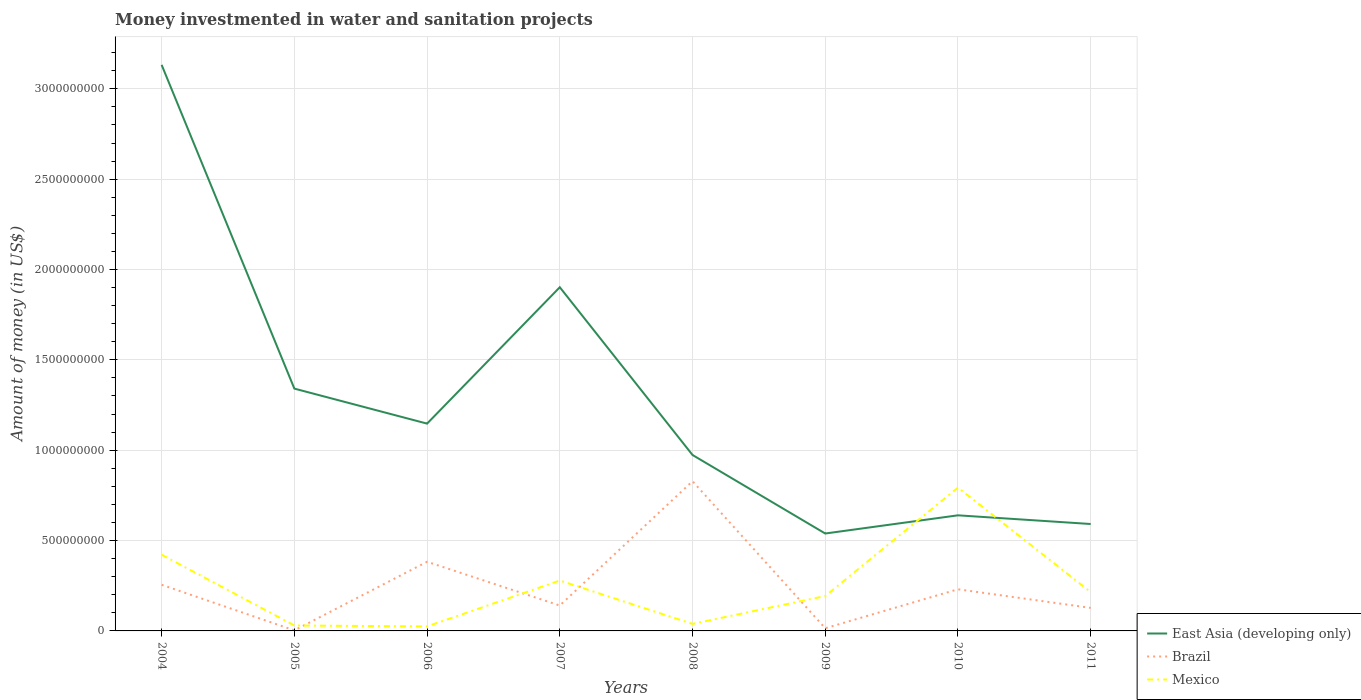How many different coloured lines are there?
Your answer should be compact. 3. Across all years, what is the maximum money investmented in water and sanitation projects in Mexico?
Your answer should be very brief. 2.50e+07. In which year was the money investmented in water and sanitation projects in East Asia (developing only) maximum?
Offer a very short reply. 2009. What is the total money investmented in water and sanitation projects in Mexico in the graph?
Keep it short and to the point. 2.29e+08. What is the difference between the highest and the second highest money investmented in water and sanitation projects in East Asia (developing only)?
Offer a very short reply. 2.59e+09. What is the difference between two consecutive major ticks on the Y-axis?
Give a very brief answer. 5.00e+08. Are the values on the major ticks of Y-axis written in scientific E-notation?
Make the answer very short. No. Does the graph contain any zero values?
Your response must be concise. No. Does the graph contain grids?
Ensure brevity in your answer.  Yes. Where does the legend appear in the graph?
Your answer should be very brief. Bottom right. How many legend labels are there?
Offer a terse response. 3. What is the title of the graph?
Offer a very short reply. Money investmented in water and sanitation projects. Does "Belgium" appear as one of the legend labels in the graph?
Provide a short and direct response. No. What is the label or title of the Y-axis?
Give a very brief answer. Amount of money (in US$). What is the Amount of money (in US$) of East Asia (developing only) in 2004?
Your answer should be very brief. 3.13e+09. What is the Amount of money (in US$) in Brazil in 2004?
Offer a very short reply. 2.55e+08. What is the Amount of money (in US$) in Mexico in 2004?
Offer a very short reply. 4.22e+08. What is the Amount of money (in US$) of East Asia (developing only) in 2005?
Provide a succinct answer. 1.34e+09. What is the Amount of money (in US$) in Brazil in 2005?
Your answer should be very brief. 3.16e+06. What is the Amount of money (in US$) in Mexico in 2005?
Your answer should be very brief. 3.00e+07. What is the Amount of money (in US$) of East Asia (developing only) in 2006?
Offer a terse response. 1.15e+09. What is the Amount of money (in US$) in Brazil in 2006?
Give a very brief answer. 3.83e+08. What is the Amount of money (in US$) in Mexico in 2006?
Make the answer very short. 2.50e+07. What is the Amount of money (in US$) in East Asia (developing only) in 2007?
Make the answer very short. 1.90e+09. What is the Amount of money (in US$) in Brazil in 2007?
Give a very brief answer. 1.41e+08. What is the Amount of money (in US$) of Mexico in 2007?
Keep it short and to the point. 2.79e+08. What is the Amount of money (in US$) in East Asia (developing only) in 2008?
Give a very brief answer. 9.74e+08. What is the Amount of money (in US$) in Brazil in 2008?
Keep it short and to the point. 8.28e+08. What is the Amount of money (in US$) of Mexico in 2008?
Your answer should be compact. 3.89e+07. What is the Amount of money (in US$) of East Asia (developing only) in 2009?
Your response must be concise. 5.39e+08. What is the Amount of money (in US$) in Brazil in 2009?
Keep it short and to the point. 1.48e+07. What is the Amount of money (in US$) of Mexico in 2009?
Ensure brevity in your answer.  1.93e+08. What is the Amount of money (in US$) of East Asia (developing only) in 2010?
Offer a terse response. 6.40e+08. What is the Amount of money (in US$) of Brazil in 2010?
Your response must be concise. 2.30e+08. What is the Amount of money (in US$) in Mexico in 2010?
Ensure brevity in your answer.  7.93e+08. What is the Amount of money (in US$) in East Asia (developing only) in 2011?
Your response must be concise. 5.92e+08. What is the Amount of money (in US$) of Brazil in 2011?
Ensure brevity in your answer.  1.28e+08. What is the Amount of money (in US$) of Mexico in 2011?
Offer a very short reply. 2.15e+08. Across all years, what is the maximum Amount of money (in US$) of East Asia (developing only)?
Give a very brief answer. 3.13e+09. Across all years, what is the maximum Amount of money (in US$) in Brazil?
Your response must be concise. 8.28e+08. Across all years, what is the maximum Amount of money (in US$) of Mexico?
Your answer should be very brief. 7.93e+08. Across all years, what is the minimum Amount of money (in US$) in East Asia (developing only)?
Your answer should be very brief. 5.39e+08. Across all years, what is the minimum Amount of money (in US$) in Brazil?
Make the answer very short. 3.16e+06. Across all years, what is the minimum Amount of money (in US$) in Mexico?
Keep it short and to the point. 2.50e+07. What is the total Amount of money (in US$) in East Asia (developing only) in the graph?
Provide a short and direct response. 1.03e+1. What is the total Amount of money (in US$) in Brazil in the graph?
Make the answer very short. 1.98e+09. What is the total Amount of money (in US$) in Mexico in the graph?
Provide a succinct answer. 2.00e+09. What is the difference between the Amount of money (in US$) in East Asia (developing only) in 2004 and that in 2005?
Offer a terse response. 1.79e+09. What is the difference between the Amount of money (in US$) in Brazil in 2004 and that in 2005?
Your response must be concise. 2.52e+08. What is the difference between the Amount of money (in US$) of Mexico in 2004 and that in 2005?
Make the answer very short. 3.92e+08. What is the difference between the Amount of money (in US$) in East Asia (developing only) in 2004 and that in 2006?
Ensure brevity in your answer.  1.99e+09. What is the difference between the Amount of money (in US$) in Brazil in 2004 and that in 2006?
Provide a short and direct response. -1.27e+08. What is the difference between the Amount of money (in US$) of Mexico in 2004 and that in 2006?
Provide a succinct answer. 3.97e+08. What is the difference between the Amount of money (in US$) in East Asia (developing only) in 2004 and that in 2007?
Give a very brief answer. 1.23e+09. What is the difference between the Amount of money (in US$) in Brazil in 2004 and that in 2007?
Your answer should be very brief. 1.15e+08. What is the difference between the Amount of money (in US$) of Mexico in 2004 and that in 2007?
Provide a short and direct response. 1.43e+08. What is the difference between the Amount of money (in US$) in East Asia (developing only) in 2004 and that in 2008?
Your answer should be very brief. 2.16e+09. What is the difference between the Amount of money (in US$) in Brazil in 2004 and that in 2008?
Give a very brief answer. -5.73e+08. What is the difference between the Amount of money (in US$) of Mexico in 2004 and that in 2008?
Provide a short and direct response. 3.83e+08. What is the difference between the Amount of money (in US$) in East Asia (developing only) in 2004 and that in 2009?
Your answer should be compact. 2.59e+09. What is the difference between the Amount of money (in US$) in Brazil in 2004 and that in 2009?
Give a very brief answer. 2.41e+08. What is the difference between the Amount of money (in US$) in Mexico in 2004 and that in 2009?
Your response must be concise. 2.29e+08. What is the difference between the Amount of money (in US$) of East Asia (developing only) in 2004 and that in 2010?
Provide a succinct answer. 2.49e+09. What is the difference between the Amount of money (in US$) in Brazil in 2004 and that in 2010?
Make the answer very short. 2.49e+07. What is the difference between the Amount of money (in US$) of Mexico in 2004 and that in 2010?
Give a very brief answer. -3.71e+08. What is the difference between the Amount of money (in US$) of East Asia (developing only) in 2004 and that in 2011?
Your answer should be very brief. 2.54e+09. What is the difference between the Amount of money (in US$) of Brazil in 2004 and that in 2011?
Your answer should be compact. 1.28e+08. What is the difference between the Amount of money (in US$) in Mexico in 2004 and that in 2011?
Your answer should be compact. 2.07e+08. What is the difference between the Amount of money (in US$) of East Asia (developing only) in 2005 and that in 2006?
Provide a short and direct response. 1.94e+08. What is the difference between the Amount of money (in US$) in Brazil in 2005 and that in 2006?
Offer a terse response. -3.79e+08. What is the difference between the Amount of money (in US$) in East Asia (developing only) in 2005 and that in 2007?
Give a very brief answer. -5.61e+08. What is the difference between the Amount of money (in US$) of Brazil in 2005 and that in 2007?
Keep it short and to the point. -1.37e+08. What is the difference between the Amount of money (in US$) in Mexico in 2005 and that in 2007?
Make the answer very short. -2.49e+08. What is the difference between the Amount of money (in US$) of East Asia (developing only) in 2005 and that in 2008?
Give a very brief answer. 3.67e+08. What is the difference between the Amount of money (in US$) in Brazil in 2005 and that in 2008?
Make the answer very short. -8.25e+08. What is the difference between the Amount of money (in US$) in Mexico in 2005 and that in 2008?
Provide a succinct answer. -8.90e+06. What is the difference between the Amount of money (in US$) of East Asia (developing only) in 2005 and that in 2009?
Ensure brevity in your answer.  8.02e+08. What is the difference between the Amount of money (in US$) of Brazil in 2005 and that in 2009?
Keep it short and to the point. -1.16e+07. What is the difference between the Amount of money (in US$) in Mexico in 2005 and that in 2009?
Keep it short and to the point. -1.63e+08. What is the difference between the Amount of money (in US$) in East Asia (developing only) in 2005 and that in 2010?
Offer a very short reply. 7.01e+08. What is the difference between the Amount of money (in US$) of Brazil in 2005 and that in 2010?
Your response must be concise. -2.27e+08. What is the difference between the Amount of money (in US$) of Mexico in 2005 and that in 2010?
Your answer should be very brief. -7.63e+08. What is the difference between the Amount of money (in US$) of East Asia (developing only) in 2005 and that in 2011?
Provide a short and direct response. 7.49e+08. What is the difference between the Amount of money (in US$) in Brazil in 2005 and that in 2011?
Ensure brevity in your answer.  -1.24e+08. What is the difference between the Amount of money (in US$) of Mexico in 2005 and that in 2011?
Offer a terse response. -1.85e+08. What is the difference between the Amount of money (in US$) in East Asia (developing only) in 2006 and that in 2007?
Give a very brief answer. -7.55e+08. What is the difference between the Amount of money (in US$) in Brazil in 2006 and that in 2007?
Your answer should be compact. 2.42e+08. What is the difference between the Amount of money (in US$) of Mexico in 2006 and that in 2007?
Your answer should be compact. -2.54e+08. What is the difference between the Amount of money (in US$) in East Asia (developing only) in 2006 and that in 2008?
Give a very brief answer. 1.74e+08. What is the difference between the Amount of money (in US$) of Brazil in 2006 and that in 2008?
Give a very brief answer. -4.46e+08. What is the difference between the Amount of money (in US$) of Mexico in 2006 and that in 2008?
Offer a terse response. -1.39e+07. What is the difference between the Amount of money (in US$) in East Asia (developing only) in 2006 and that in 2009?
Keep it short and to the point. 6.08e+08. What is the difference between the Amount of money (in US$) in Brazil in 2006 and that in 2009?
Offer a terse response. 3.68e+08. What is the difference between the Amount of money (in US$) in Mexico in 2006 and that in 2009?
Your answer should be very brief. -1.68e+08. What is the difference between the Amount of money (in US$) in East Asia (developing only) in 2006 and that in 2010?
Give a very brief answer. 5.07e+08. What is the difference between the Amount of money (in US$) of Brazil in 2006 and that in 2010?
Make the answer very short. 1.52e+08. What is the difference between the Amount of money (in US$) of Mexico in 2006 and that in 2010?
Your answer should be compact. -7.68e+08. What is the difference between the Amount of money (in US$) of East Asia (developing only) in 2006 and that in 2011?
Make the answer very short. 5.56e+08. What is the difference between the Amount of money (in US$) of Brazil in 2006 and that in 2011?
Ensure brevity in your answer.  2.55e+08. What is the difference between the Amount of money (in US$) of Mexico in 2006 and that in 2011?
Give a very brief answer. -1.90e+08. What is the difference between the Amount of money (in US$) of East Asia (developing only) in 2007 and that in 2008?
Your response must be concise. 9.28e+08. What is the difference between the Amount of money (in US$) of Brazil in 2007 and that in 2008?
Your answer should be very brief. -6.88e+08. What is the difference between the Amount of money (in US$) of Mexico in 2007 and that in 2008?
Your answer should be very brief. 2.40e+08. What is the difference between the Amount of money (in US$) of East Asia (developing only) in 2007 and that in 2009?
Your response must be concise. 1.36e+09. What is the difference between the Amount of money (in US$) of Brazil in 2007 and that in 2009?
Make the answer very short. 1.26e+08. What is the difference between the Amount of money (in US$) in Mexico in 2007 and that in 2009?
Ensure brevity in your answer.  8.58e+07. What is the difference between the Amount of money (in US$) in East Asia (developing only) in 2007 and that in 2010?
Provide a short and direct response. 1.26e+09. What is the difference between the Amount of money (in US$) of Brazil in 2007 and that in 2010?
Give a very brief answer. -8.98e+07. What is the difference between the Amount of money (in US$) in Mexico in 2007 and that in 2010?
Make the answer very short. -5.14e+08. What is the difference between the Amount of money (in US$) of East Asia (developing only) in 2007 and that in 2011?
Provide a succinct answer. 1.31e+09. What is the difference between the Amount of money (in US$) in Brazil in 2007 and that in 2011?
Offer a very short reply. 1.31e+07. What is the difference between the Amount of money (in US$) of Mexico in 2007 and that in 2011?
Keep it short and to the point. 6.40e+07. What is the difference between the Amount of money (in US$) in East Asia (developing only) in 2008 and that in 2009?
Ensure brevity in your answer.  4.35e+08. What is the difference between the Amount of money (in US$) in Brazil in 2008 and that in 2009?
Keep it short and to the point. 8.14e+08. What is the difference between the Amount of money (in US$) of Mexico in 2008 and that in 2009?
Provide a short and direct response. -1.54e+08. What is the difference between the Amount of money (in US$) in East Asia (developing only) in 2008 and that in 2010?
Ensure brevity in your answer.  3.34e+08. What is the difference between the Amount of money (in US$) of Brazil in 2008 and that in 2010?
Give a very brief answer. 5.98e+08. What is the difference between the Amount of money (in US$) of Mexico in 2008 and that in 2010?
Offer a very short reply. -7.54e+08. What is the difference between the Amount of money (in US$) in East Asia (developing only) in 2008 and that in 2011?
Your response must be concise. 3.82e+08. What is the difference between the Amount of money (in US$) in Brazil in 2008 and that in 2011?
Keep it short and to the point. 7.01e+08. What is the difference between the Amount of money (in US$) in Mexico in 2008 and that in 2011?
Offer a very short reply. -1.76e+08. What is the difference between the Amount of money (in US$) of East Asia (developing only) in 2009 and that in 2010?
Offer a terse response. -1.01e+08. What is the difference between the Amount of money (in US$) in Brazil in 2009 and that in 2010?
Ensure brevity in your answer.  -2.16e+08. What is the difference between the Amount of money (in US$) in Mexico in 2009 and that in 2010?
Give a very brief answer. -6.00e+08. What is the difference between the Amount of money (in US$) of East Asia (developing only) in 2009 and that in 2011?
Provide a succinct answer. -5.26e+07. What is the difference between the Amount of money (in US$) in Brazil in 2009 and that in 2011?
Offer a very short reply. -1.13e+08. What is the difference between the Amount of money (in US$) in Mexico in 2009 and that in 2011?
Your response must be concise. -2.18e+07. What is the difference between the Amount of money (in US$) of East Asia (developing only) in 2010 and that in 2011?
Your answer should be compact. 4.81e+07. What is the difference between the Amount of money (in US$) in Brazil in 2010 and that in 2011?
Keep it short and to the point. 1.03e+08. What is the difference between the Amount of money (in US$) in Mexico in 2010 and that in 2011?
Offer a very short reply. 5.78e+08. What is the difference between the Amount of money (in US$) in East Asia (developing only) in 2004 and the Amount of money (in US$) in Brazil in 2005?
Provide a succinct answer. 3.13e+09. What is the difference between the Amount of money (in US$) of East Asia (developing only) in 2004 and the Amount of money (in US$) of Mexico in 2005?
Ensure brevity in your answer.  3.10e+09. What is the difference between the Amount of money (in US$) of Brazil in 2004 and the Amount of money (in US$) of Mexico in 2005?
Provide a short and direct response. 2.25e+08. What is the difference between the Amount of money (in US$) of East Asia (developing only) in 2004 and the Amount of money (in US$) of Brazil in 2006?
Your answer should be very brief. 2.75e+09. What is the difference between the Amount of money (in US$) in East Asia (developing only) in 2004 and the Amount of money (in US$) in Mexico in 2006?
Keep it short and to the point. 3.11e+09. What is the difference between the Amount of money (in US$) in Brazil in 2004 and the Amount of money (in US$) in Mexico in 2006?
Your response must be concise. 2.30e+08. What is the difference between the Amount of money (in US$) of East Asia (developing only) in 2004 and the Amount of money (in US$) of Brazil in 2007?
Ensure brevity in your answer.  2.99e+09. What is the difference between the Amount of money (in US$) in East Asia (developing only) in 2004 and the Amount of money (in US$) in Mexico in 2007?
Provide a succinct answer. 2.85e+09. What is the difference between the Amount of money (in US$) of Brazil in 2004 and the Amount of money (in US$) of Mexico in 2007?
Ensure brevity in your answer.  -2.35e+07. What is the difference between the Amount of money (in US$) of East Asia (developing only) in 2004 and the Amount of money (in US$) of Brazil in 2008?
Provide a succinct answer. 2.30e+09. What is the difference between the Amount of money (in US$) of East Asia (developing only) in 2004 and the Amount of money (in US$) of Mexico in 2008?
Ensure brevity in your answer.  3.09e+09. What is the difference between the Amount of money (in US$) in Brazil in 2004 and the Amount of money (in US$) in Mexico in 2008?
Keep it short and to the point. 2.16e+08. What is the difference between the Amount of money (in US$) of East Asia (developing only) in 2004 and the Amount of money (in US$) of Brazil in 2009?
Give a very brief answer. 3.12e+09. What is the difference between the Amount of money (in US$) in East Asia (developing only) in 2004 and the Amount of money (in US$) in Mexico in 2009?
Your answer should be compact. 2.94e+09. What is the difference between the Amount of money (in US$) of Brazil in 2004 and the Amount of money (in US$) of Mexico in 2009?
Your answer should be very brief. 6.23e+07. What is the difference between the Amount of money (in US$) in East Asia (developing only) in 2004 and the Amount of money (in US$) in Brazil in 2010?
Make the answer very short. 2.90e+09. What is the difference between the Amount of money (in US$) in East Asia (developing only) in 2004 and the Amount of money (in US$) in Mexico in 2010?
Provide a succinct answer. 2.34e+09. What is the difference between the Amount of money (in US$) of Brazil in 2004 and the Amount of money (in US$) of Mexico in 2010?
Give a very brief answer. -5.38e+08. What is the difference between the Amount of money (in US$) in East Asia (developing only) in 2004 and the Amount of money (in US$) in Brazil in 2011?
Provide a short and direct response. 3.00e+09. What is the difference between the Amount of money (in US$) in East Asia (developing only) in 2004 and the Amount of money (in US$) in Mexico in 2011?
Make the answer very short. 2.92e+09. What is the difference between the Amount of money (in US$) in Brazil in 2004 and the Amount of money (in US$) in Mexico in 2011?
Provide a short and direct response. 4.05e+07. What is the difference between the Amount of money (in US$) in East Asia (developing only) in 2005 and the Amount of money (in US$) in Brazil in 2006?
Provide a short and direct response. 9.58e+08. What is the difference between the Amount of money (in US$) of East Asia (developing only) in 2005 and the Amount of money (in US$) of Mexico in 2006?
Provide a short and direct response. 1.32e+09. What is the difference between the Amount of money (in US$) of Brazil in 2005 and the Amount of money (in US$) of Mexico in 2006?
Give a very brief answer. -2.18e+07. What is the difference between the Amount of money (in US$) of East Asia (developing only) in 2005 and the Amount of money (in US$) of Brazil in 2007?
Keep it short and to the point. 1.20e+09. What is the difference between the Amount of money (in US$) in East Asia (developing only) in 2005 and the Amount of money (in US$) in Mexico in 2007?
Offer a very short reply. 1.06e+09. What is the difference between the Amount of money (in US$) of Brazil in 2005 and the Amount of money (in US$) of Mexico in 2007?
Make the answer very short. -2.76e+08. What is the difference between the Amount of money (in US$) in East Asia (developing only) in 2005 and the Amount of money (in US$) in Brazil in 2008?
Provide a succinct answer. 5.13e+08. What is the difference between the Amount of money (in US$) of East Asia (developing only) in 2005 and the Amount of money (in US$) of Mexico in 2008?
Your answer should be very brief. 1.30e+09. What is the difference between the Amount of money (in US$) in Brazil in 2005 and the Amount of money (in US$) in Mexico in 2008?
Keep it short and to the point. -3.57e+07. What is the difference between the Amount of money (in US$) in East Asia (developing only) in 2005 and the Amount of money (in US$) in Brazil in 2009?
Make the answer very short. 1.33e+09. What is the difference between the Amount of money (in US$) in East Asia (developing only) in 2005 and the Amount of money (in US$) in Mexico in 2009?
Keep it short and to the point. 1.15e+09. What is the difference between the Amount of money (in US$) of Brazil in 2005 and the Amount of money (in US$) of Mexico in 2009?
Your answer should be very brief. -1.90e+08. What is the difference between the Amount of money (in US$) in East Asia (developing only) in 2005 and the Amount of money (in US$) in Brazil in 2010?
Give a very brief answer. 1.11e+09. What is the difference between the Amount of money (in US$) in East Asia (developing only) in 2005 and the Amount of money (in US$) in Mexico in 2010?
Your answer should be compact. 5.48e+08. What is the difference between the Amount of money (in US$) of Brazil in 2005 and the Amount of money (in US$) of Mexico in 2010?
Offer a terse response. -7.90e+08. What is the difference between the Amount of money (in US$) in East Asia (developing only) in 2005 and the Amount of money (in US$) in Brazil in 2011?
Provide a succinct answer. 1.21e+09. What is the difference between the Amount of money (in US$) in East Asia (developing only) in 2005 and the Amount of money (in US$) in Mexico in 2011?
Offer a terse response. 1.13e+09. What is the difference between the Amount of money (in US$) of Brazil in 2005 and the Amount of money (in US$) of Mexico in 2011?
Your response must be concise. -2.12e+08. What is the difference between the Amount of money (in US$) in East Asia (developing only) in 2006 and the Amount of money (in US$) in Brazil in 2007?
Your response must be concise. 1.01e+09. What is the difference between the Amount of money (in US$) of East Asia (developing only) in 2006 and the Amount of money (in US$) of Mexico in 2007?
Give a very brief answer. 8.68e+08. What is the difference between the Amount of money (in US$) in Brazil in 2006 and the Amount of money (in US$) in Mexico in 2007?
Keep it short and to the point. 1.04e+08. What is the difference between the Amount of money (in US$) in East Asia (developing only) in 2006 and the Amount of money (in US$) in Brazil in 2008?
Provide a short and direct response. 3.19e+08. What is the difference between the Amount of money (in US$) of East Asia (developing only) in 2006 and the Amount of money (in US$) of Mexico in 2008?
Offer a terse response. 1.11e+09. What is the difference between the Amount of money (in US$) in Brazil in 2006 and the Amount of money (in US$) in Mexico in 2008?
Offer a terse response. 3.44e+08. What is the difference between the Amount of money (in US$) of East Asia (developing only) in 2006 and the Amount of money (in US$) of Brazil in 2009?
Your response must be concise. 1.13e+09. What is the difference between the Amount of money (in US$) in East Asia (developing only) in 2006 and the Amount of money (in US$) in Mexico in 2009?
Provide a short and direct response. 9.54e+08. What is the difference between the Amount of money (in US$) in Brazil in 2006 and the Amount of money (in US$) in Mexico in 2009?
Make the answer very short. 1.90e+08. What is the difference between the Amount of money (in US$) of East Asia (developing only) in 2006 and the Amount of money (in US$) of Brazil in 2010?
Provide a short and direct response. 9.17e+08. What is the difference between the Amount of money (in US$) in East Asia (developing only) in 2006 and the Amount of money (in US$) in Mexico in 2010?
Your answer should be very brief. 3.54e+08. What is the difference between the Amount of money (in US$) in Brazil in 2006 and the Amount of money (in US$) in Mexico in 2010?
Provide a succinct answer. -4.10e+08. What is the difference between the Amount of money (in US$) of East Asia (developing only) in 2006 and the Amount of money (in US$) of Brazil in 2011?
Your response must be concise. 1.02e+09. What is the difference between the Amount of money (in US$) in East Asia (developing only) in 2006 and the Amount of money (in US$) in Mexico in 2011?
Your answer should be compact. 9.32e+08. What is the difference between the Amount of money (in US$) of Brazil in 2006 and the Amount of money (in US$) of Mexico in 2011?
Ensure brevity in your answer.  1.68e+08. What is the difference between the Amount of money (in US$) of East Asia (developing only) in 2007 and the Amount of money (in US$) of Brazil in 2008?
Ensure brevity in your answer.  1.07e+09. What is the difference between the Amount of money (in US$) of East Asia (developing only) in 2007 and the Amount of money (in US$) of Mexico in 2008?
Offer a very short reply. 1.86e+09. What is the difference between the Amount of money (in US$) in Brazil in 2007 and the Amount of money (in US$) in Mexico in 2008?
Keep it short and to the point. 1.02e+08. What is the difference between the Amount of money (in US$) in East Asia (developing only) in 2007 and the Amount of money (in US$) in Brazil in 2009?
Offer a terse response. 1.89e+09. What is the difference between the Amount of money (in US$) in East Asia (developing only) in 2007 and the Amount of money (in US$) in Mexico in 2009?
Provide a short and direct response. 1.71e+09. What is the difference between the Amount of money (in US$) in Brazil in 2007 and the Amount of money (in US$) in Mexico in 2009?
Your answer should be very brief. -5.24e+07. What is the difference between the Amount of money (in US$) of East Asia (developing only) in 2007 and the Amount of money (in US$) of Brazil in 2010?
Offer a terse response. 1.67e+09. What is the difference between the Amount of money (in US$) of East Asia (developing only) in 2007 and the Amount of money (in US$) of Mexico in 2010?
Your answer should be compact. 1.11e+09. What is the difference between the Amount of money (in US$) of Brazil in 2007 and the Amount of money (in US$) of Mexico in 2010?
Keep it short and to the point. -6.52e+08. What is the difference between the Amount of money (in US$) in East Asia (developing only) in 2007 and the Amount of money (in US$) in Brazil in 2011?
Offer a terse response. 1.77e+09. What is the difference between the Amount of money (in US$) in East Asia (developing only) in 2007 and the Amount of money (in US$) in Mexico in 2011?
Ensure brevity in your answer.  1.69e+09. What is the difference between the Amount of money (in US$) in Brazil in 2007 and the Amount of money (in US$) in Mexico in 2011?
Provide a short and direct response. -7.42e+07. What is the difference between the Amount of money (in US$) of East Asia (developing only) in 2008 and the Amount of money (in US$) of Brazil in 2009?
Your response must be concise. 9.59e+08. What is the difference between the Amount of money (in US$) of East Asia (developing only) in 2008 and the Amount of money (in US$) of Mexico in 2009?
Make the answer very short. 7.81e+08. What is the difference between the Amount of money (in US$) of Brazil in 2008 and the Amount of money (in US$) of Mexico in 2009?
Your answer should be compact. 6.35e+08. What is the difference between the Amount of money (in US$) of East Asia (developing only) in 2008 and the Amount of money (in US$) of Brazil in 2010?
Provide a short and direct response. 7.43e+08. What is the difference between the Amount of money (in US$) of East Asia (developing only) in 2008 and the Amount of money (in US$) of Mexico in 2010?
Offer a very short reply. 1.81e+08. What is the difference between the Amount of money (in US$) of Brazil in 2008 and the Amount of money (in US$) of Mexico in 2010?
Your answer should be very brief. 3.54e+07. What is the difference between the Amount of money (in US$) in East Asia (developing only) in 2008 and the Amount of money (in US$) in Brazil in 2011?
Make the answer very short. 8.46e+08. What is the difference between the Amount of money (in US$) of East Asia (developing only) in 2008 and the Amount of money (in US$) of Mexico in 2011?
Offer a terse response. 7.59e+08. What is the difference between the Amount of money (in US$) in Brazil in 2008 and the Amount of money (in US$) in Mexico in 2011?
Keep it short and to the point. 6.14e+08. What is the difference between the Amount of money (in US$) in East Asia (developing only) in 2009 and the Amount of money (in US$) in Brazil in 2010?
Ensure brevity in your answer.  3.09e+08. What is the difference between the Amount of money (in US$) of East Asia (developing only) in 2009 and the Amount of money (in US$) of Mexico in 2010?
Your response must be concise. -2.54e+08. What is the difference between the Amount of money (in US$) of Brazil in 2009 and the Amount of money (in US$) of Mexico in 2010?
Your answer should be very brief. -7.78e+08. What is the difference between the Amount of money (in US$) in East Asia (developing only) in 2009 and the Amount of money (in US$) in Brazil in 2011?
Make the answer very short. 4.12e+08. What is the difference between the Amount of money (in US$) of East Asia (developing only) in 2009 and the Amount of money (in US$) of Mexico in 2011?
Make the answer very short. 3.24e+08. What is the difference between the Amount of money (in US$) in Brazil in 2009 and the Amount of money (in US$) in Mexico in 2011?
Ensure brevity in your answer.  -2.00e+08. What is the difference between the Amount of money (in US$) of East Asia (developing only) in 2010 and the Amount of money (in US$) of Brazil in 2011?
Provide a succinct answer. 5.12e+08. What is the difference between the Amount of money (in US$) of East Asia (developing only) in 2010 and the Amount of money (in US$) of Mexico in 2011?
Ensure brevity in your answer.  4.25e+08. What is the difference between the Amount of money (in US$) of Brazil in 2010 and the Amount of money (in US$) of Mexico in 2011?
Your answer should be compact. 1.56e+07. What is the average Amount of money (in US$) in East Asia (developing only) per year?
Ensure brevity in your answer.  1.28e+09. What is the average Amount of money (in US$) of Brazil per year?
Make the answer very short. 2.48e+08. What is the average Amount of money (in US$) in Mexico per year?
Offer a very short reply. 2.49e+08. In the year 2004, what is the difference between the Amount of money (in US$) of East Asia (developing only) and Amount of money (in US$) of Brazil?
Keep it short and to the point. 2.88e+09. In the year 2004, what is the difference between the Amount of money (in US$) of East Asia (developing only) and Amount of money (in US$) of Mexico?
Your response must be concise. 2.71e+09. In the year 2004, what is the difference between the Amount of money (in US$) in Brazil and Amount of money (in US$) in Mexico?
Provide a succinct answer. -1.66e+08. In the year 2005, what is the difference between the Amount of money (in US$) of East Asia (developing only) and Amount of money (in US$) of Brazil?
Offer a very short reply. 1.34e+09. In the year 2005, what is the difference between the Amount of money (in US$) of East Asia (developing only) and Amount of money (in US$) of Mexico?
Provide a short and direct response. 1.31e+09. In the year 2005, what is the difference between the Amount of money (in US$) of Brazil and Amount of money (in US$) of Mexico?
Offer a very short reply. -2.68e+07. In the year 2006, what is the difference between the Amount of money (in US$) of East Asia (developing only) and Amount of money (in US$) of Brazil?
Offer a terse response. 7.65e+08. In the year 2006, what is the difference between the Amount of money (in US$) of East Asia (developing only) and Amount of money (in US$) of Mexico?
Your answer should be very brief. 1.12e+09. In the year 2006, what is the difference between the Amount of money (in US$) of Brazil and Amount of money (in US$) of Mexico?
Your answer should be very brief. 3.58e+08. In the year 2007, what is the difference between the Amount of money (in US$) in East Asia (developing only) and Amount of money (in US$) in Brazil?
Offer a very short reply. 1.76e+09. In the year 2007, what is the difference between the Amount of money (in US$) of East Asia (developing only) and Amount of money (in US$) of Mexico?
Make the answer very short. 1.62e+09. In the year 2007, what is the difference between the Amount of money (in US$) of Brazil and Amount of money (in US$) of Mexico?
Ensure brevity in your answer.  -1.38e+08. In the year 2008, what is the difference between the Amount of money (in US$) in East Asia (developing only) and Amount of money (in US$) in Brazil?
Provide a succinct answer. 1.45e+08. In the year 2008, what is the difference between the Amount of money (in US$) of East Asia (developing only) and Amount of money (in US$) of Mexico?
Provide a succinct answer. 9.35e+08. In the year 2008, what is the difference between the Amount of money (in US$) in Brazil and Amount of money (in US$) in Mexico?
Provide a short and direct response. 7.90e+08. In the year 2009, what is the difference between the Amount of money (in US$) of East Asia (developing only) and Amount of money (in US$) of Brazil?
Your response must be concise. 5.24e+08. In the year 2009, what is the difference between the Amount of money (in US$) of East Asia (developing only) and Amount of money (in US$) of Mexico?
Keep it short and to the point. 3.46e+08. In the year 2009, what is the difference between the Amount of money (in US$) in Brazil and Amount of money (in US$) in Mexico?
Provide a succinct answer. -1.78e+08. In the year 2010, what is the difference between the Amount of money (in US$) of East Asia (developing only) and Amount of money (in US$) of Brazil?
Provide a succinct answer. 4.09e+08. In the year 2010, what is the difference between the Amount of money (in US$) in East Asia (developing only) and Amount of money (in US$) in Mexico?
Make the answer very short. -1.53e+08. In the year 2010, what is the difference between the Amount of money (in US$) of Brazil and Amount of money (in US$) of Mexico?
Keep it short and to the point. -5.63e+08. In the year 2011, what is the difference between the Amount of money (in US$) of East Asia (developing only) and Amount of money (in US$) of Brazil?
Provide a succinct answer. 4.64e+08. In the year 2011, what is the difference between the Amount of money (in US$) of East Asia (developing only) and Amount of money (in US$) of Mexico?
Make the answer very short. 3.77e+08. In the year 2011, what is the difference between the Amount of money (in US$) in Brazil and Amount of money (in US$) in Mexico?
Your answer should be compact. -8.73e+07. What is the ratio of the Amount of money (in US$) in East Asia (developing only) in 2004 to that in 2005?
Keep it short and to the point. 2.34. What is the ratio of the Amount of money (in US$) in Brazil in 2004 to that in 2005?
Make the answer very short. 80.7. What is the ratio of the Amount of money (in US$) of Mexico in 2004 to that in 2005?
Your response must be concise. 14.06. What is the ratio of the Amount of money (in US$) of East Asia (developing only) in 2004 to that in 2006?
Ensure brevity in your answer.  2.73. What is the ratio of the Amount of money (in US$) in Brazil in 2004 to that in 2006?
Your response must be concise. 0.67. What is the ratio of the Amount of money (in US$) of Mexico in 2004 to that in 2006?
Give a very brief answer. 16.87. What is the ratio of the Amount of money (in US$) in East Asia (developing only) in 2004 to that in 2007?
Provide a short and direct response. 1.65. What is the ratio of the Amount of money (in US$) of Brazil in 2004 to that in 2007?
Keep it short and to the point. 1.82. What is the ratio of the Amount of money (in US$) of Mexico in 2004 to that in 2007?
Keep it short and to the point. 1.51. What is the ratio of the Amount of money (in US$) of East Asia (developing only) in 2004 to that in 2008?
Your answer should be compact. 3.22. What is the ratio of the Amount of money (in US$) of Brazil in 2004 to that in 2008?
Give a very brief answer. 0.31. What is the ratio of the Amount of money (in US$) in Mexico in 2004 to that in 2008?
Your answer should be compact. 10.84. What is the ratio of the Amount of money (in US$) of East Asia (developing only) in 2004 to that in 2009?
Your answer should be compact. 5.81. What is the ratio of the Amount of money (in US$) in Brazil in 2004 to that in 2009?
Make the answer very short. 17.25. What is the ratio of the Amount of money (in US$) in Mexico in 2004 to that in 2009?
Make the answer very short. 2.19. What is the ratio of the Amount of money (in US$) in East Asia (developing only) in 2004 to that in 2010?
Your answer should be compact. 4.9. What is the ratio of the Amount of money (in US$) in Brazil in 2004 to that in 2010?
Offer a terse response. 1.11. What is the ratio of the Amount of money (in US$) in Mexico in 2004 to that in 2010?
Your response must be concise. 0.53. What is the ratio of the Amount of money (in US$) in East Asia (developing only) in 2004 to that in 2011?
Your response must be concise. 5.29. What is the ratio of the Amount of money (in US$) in Brazil in 2004 to that in 2011?
Your response must be concise. 2. What is the ratio of the Amount of money (in US$) in Mexico in 2004 to that in 2011?
Your answer should be compact. 1.96. What is the ratio of the Amount of money (in US$) in East Asia (developing only) in 2005 to that in 2006?
Provide a succinct answer. 1.17. What is the ratio of the Amount of money (in US$) in Brazil in 2005 to that in 2006?
Give a very brief answer. 0.01. What is the ratio of the Amount of money (in US$) in East Asia (developing only) in 2005 to that in 2007?
Ensure brevity in your answer.  0.71. What is the ratio of the Amount of money (in US$) in Brazil in 2005 to that in 2007?
Offer a very short reply. 0.02. What is the ratio of the Amount of money (in US$) in Mexico in 2005 to that in 2007?
Keep it short and to the point. 0.11. What is the ratio of the Amount of money (in US$) in East Asia (developing only) in 2005 to that in 2008?
Offer a very short reply. 1.38. What is the ratio of the Amount of money (in US$) of Brazil in 2005 to that in 2008?
Your answer should be very brief. 0. What is the ratio of the Amount of money (in US$) in Mexico in 2005 to that in 2008?
Your answer should be compact. 0.77. What is the ratio of the Amount of money (in US$) of East Asia (developing only) in 2005 to that in 2009?
Give a very brief answer. 2.49. What is the ratio of the Amount of money (in US$) in Brazil in 2005 to that in 2009?
Your answer should be very brief. 0.21. What is the ratio of the Amount of money (in US$) of Mexico in 2005 to that in 2009?
Make the answer very short. 0.16. What is the ratio of the Amount of money (in US$) of East Asia (developing only) in 2005 to that in 2010?
Provide a short and direct response. 2.1. What is the ratio of the Amount of money (in US$) in Brazil in 2005 to that in 2010?
Your answer should be very brief. 0.01. What is the ratio of the Amount of money (in US$) of Mexico in 2005 to that in 2010?
Your answer should be very brief. 0.04. What is the ratio of the Amount of money (in US$) of East Asia (developing only) in 2005 to that in 2011?
Offer a terse response. 2.27. What is the ratio of the Amount of money (in US$) in Brazil in 2005 to that in 2011?
Offer a terse response. 0.02. What is the ratio of the Amount of money (in US$) in Mexico in 2005 to that in 2011?
Your answer should be very brief. 0.14. What is the ratio of the Amount of money (in US$) of East Asia (developing only) in 2006 to that in 2007?
Provide a succinct answer. 0.6. What is the ratio of the Amount of money (in US$) of Brazil in 2006 to that in 2007?
Keep it short and to the point. 2.72. What is the ratio of the Amount of money (in US$) of Mexico in 2006 to that in 2007?
Give a very brief answer. 0.09. What is the ratio of the Amount of money (in US$) in East Asia (developing only) in 2006 to that in 2008?
Provide a succinct answer. 1.18. What is the ratio of the Amount of money (in US$) in Brazil in 2006 to that in 2008?
Your response must be concise. 0.46. What is the ratio of the Amount of money (in US$) of Mexico in 2006 to that in 2008?
Ensure brevity in your answer.  0.64. What is the ratio of the Amount of money (in US$) of East Asia (developing only) in 2006 to that in 2009?
Provide a short and direct response. 2.13. What is the ratio of the Amount of money (in US$) of Brazil in 2006 to that in 2009?
Ensure brevity in your answer.  25.85. What is the ratio of the Amount of money (in US$) of Mexico in 2006 to that in 2009?
Provide a succinct answer. 0.13. What is the ratio of the Amount of money (in US$) in East Asia (developing only) in 2006 to that in 2010?
Your answer should be very brief. 1.79. What is the ratio of the Amount of money (in US$) of Brazil in 2006 to that in 2010?
Provide a succinct answer. 1.66. What is the ratio of the Amount of money (in US$) in Mexico in 2006 to that in 2010?
Ensure brevity in your answer.  0.03. What is the ratio of the Amount of money (in US$) of East Asia (developing only) in 2006 to that in 2011?
Your answer should be compact. 1.94. What is the ratio of the Amount of money (in US$) of Brazil in 2006 to that in 2011?
Keep it short and to the point. 3. What is the ratio of the Amount of money (in US$) in Mexico in 2006 to that in 2011?
Offer a terse response. 0.12. What is the ratio of the Amount of money (in US$) of East Asia (developing only) in 2007 to that in 2008?
Offer a terse response. 1.95. What is the ratio of the Amount of money (in US$) in Brazil in 2007 to that in 2008?
Your answer should be compact. 0.17. What is the ratio of the Amount of money (in US$) of Mexico in 2007 to that in 2008?
Your answer should be very brief. 7.17. What is the ratio of the Amount of money (in US$) of East Asia (developing only) in 2007 to that in 2009?
Give a very brief answer. 3.53. What is the ratio of the Amount of money (in US$) in Brazil in 2007 to that in 2009?
Offer a terse response. 9.5. What is the ratio of the Amount of money (in US$) of Mexico in 2007 to that in 2009?
Your response must be concise. 1.44. What is the ratio of the Amount of money (in US$) of East Asia (developing only) in 2007 to that in 2010?
Your response must be concise. 2.97. What is the ratio of the Amount of money (in US$) in Brazil in 2007 to that in 2010?
Ensure brevity in your answer.  0.61. What is the ratio of the Amount of money (in US$) in Mexico in 2007 to that in 2010?
Offer a terse response. 0.35. What is the ratio of the Amount of money (in US$) in East Asia (developing only) in 2007 to that in 2011?
Your answer should be compact. 3.21. What is the ratio of the Amount of money (in US$) of Brazil in 2007 to that in 2011?
Ensure brevity in your answer.  1.1. What is the ratio of the Amount of money (in US$) in Mexico in 2007 to that in 2011?
Give a very brief answer. 1.3. What is the ratio of the Amount of money (in US$) in East Asia (developing only) in 2008 to that in 2009?
Ensure brevity in your answer.  1.81. What is the ratio of the Amount of money (in US$) of Brazil in 2008 to that in 2009?
Provide a succinct answer. 55.97. What is the ratio of the Amount of money (in US$) of Mexico in 2008 to that in 2009?
Make the answer very short. 0.2. What is the ratio of the Amount of money (in US$) in East Asia (developing only) in 2008 to that in 2010?
Provide a short and direct response. 1.52. What is the ratio of the Amount of money (in US$) in Brazil in 2008 to that in 2010?
Your answer should be compact. 3.6. What is the ratio of the Amount of money (in US$) in Mexico in 2008 to that in 2010?
Provide a succinct answer. 0.05. What is the ratio of the Amount of money (in US$) of East Asia (developing only) in 2008 to that in 2011?
Your answer should be compact. 1.65. What is the ratio of the Amount of money (in US$) in Brazil in 2008 to that in 2011?
Your answer should be very brief. 6.5. What is the ratio of the Amount of money (in US$) in Mexico in 2008 to that in 2011?
Your answer should be compact. 0.18. What is the ratio of the Amount of money (in US$) of East Asia (developing only) in 2009 to that in 2010?
Make the answer very short. 0.84. What is the ratio of the Amount of money (in US$) in Brazil in 2009 to that in 2010?
Provide a succinct answer. 0.06. What is the ratio of the Amount of money (in US$) of Mexico in 2009 to that in 2010?
Your answer should be compact. 0.24. What is the ratio of the Amount of money (in US$) in East Asia (developing only) in 2009 to that in 2011?
Give a very brief answer. 0.91. What is the ratio of the Amount of money (in US$) in Brazil in 2009 to that in 2011?
Offer a terse response. 0.12. What is the ratio of the Amount of money (in US$) in Mexico in 2009 to that in 2011?
Give a very brief answer. 0.9. What is the ratio of the Amount of money (in US$) of East Asia (developing only) in 2010 to that in 2011?
Give a very brief answer. 1.08. What is the ratio of the Amount of money (in US$) of Brazil in 2010 to that in 2011?
Make the answer very short. 1.81. What is the ratio of the Amount of money (in US$) in Mexico in 2010 to that in 2011?
Ensure brevity in your answer.  3.69. What is the difference between the highest and the second highest Amount of money (in US$) in East Asia (developing only)?
Your response must be concise. 1.23e+09. What is the difference between the highest and the second highest Amount of money (in US$) of Brazil?
Offer a very short reply. 4.46e+08. What is the difference between the highest and the second highest Amount of money (in US$) of Mexico?
Provide a succinct answer. 3.71e+08. What is the difference between the highest and the lowest Amount of money (in US$) in East Asia (developing only)?
Offer a terse response. 2.59e+09. What is the difference between the highest and the lowest Amount of money (in US$) of Brazil?
Provide a short and direct response. 8.25e+08. What is the difference between the highest and the lowest Amount of money (in US$) in Mexico?
Make the answer very short. 7.68e+08. 